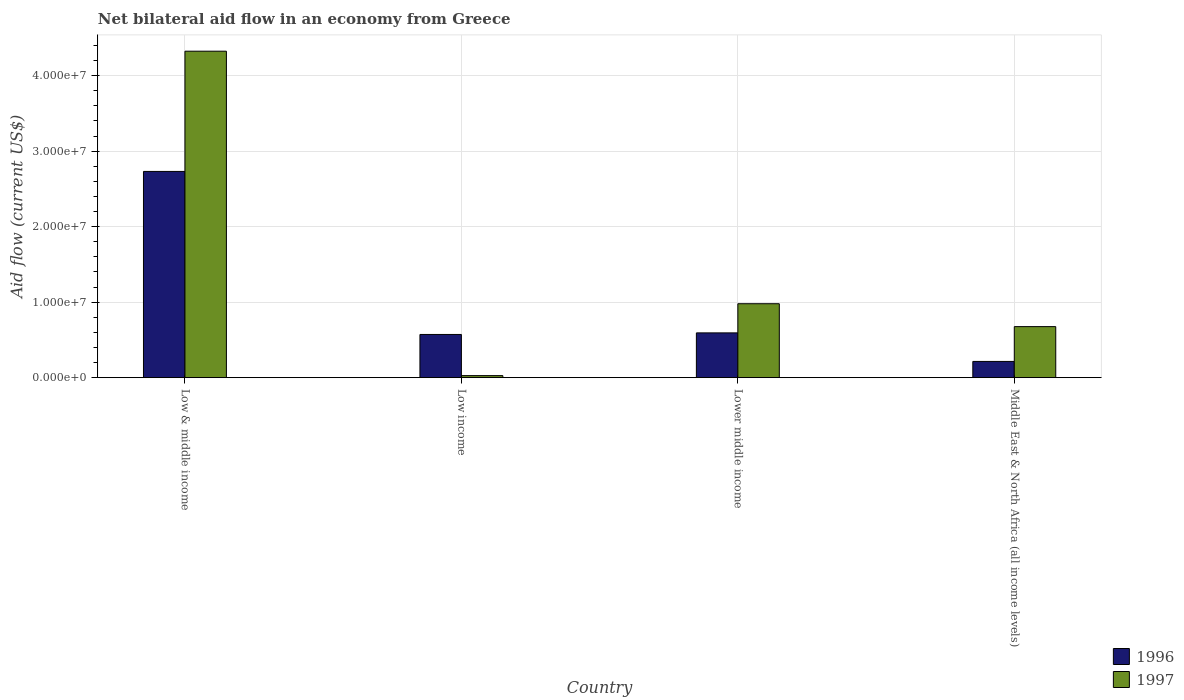How many different coloured bars are there?
Your response must be concise. 2. How many groups of bars are there?
Offer a very short reply. 4. Are the number of bars on each tick of the X-axis equal?
Your response must be concise. Yes. How many bars are there on the 4th tick from the right?
Make the answer very short. 2. What is the label of the 3rd group of bars from the left?
Offer a very short reply. Lower middle income. In how many cases, is the number of bars for a given country not equal to the number of legend labels?
Your answer should be very brief. 0. What is the net bilateral aid flow in 1997 in Low income?
Provide a short and direct response. 2.70e+05. Across all countries, what is the maximum net bilateral aid flow in 1996?
Ensure brevity in your answer.  2.73e+07. Across all countries, what is the minimum net bilateral aid flow in 1996?
Your response must be concise. 2.15e+06. In which country was the net bilateral aid flow in 1996 maximum?
Provide a short and direct response. Low & middle income. What is the total net bilateral aid flow in 1996 in the graph?
Your response must be concise. 4.11e+07. What is the difference between the net bilateral aid flow in 1997 in Low & middle income and the net bilateral aid flow in 1996 in Middle East & North Africa (all income levels)?
Provide a succinct answer. 4.11e+07. What is the average net bilateral aid flow in 1997 per country?
Give a very brief answer. 1.50e+07. What is the difference between the net bilateral aid flow of/in 1996 and net bilateral aid flow of/in 1997 in Low & middle income?
Provide a succinct answer. -1.59e+07. What is the ratio of the net bilateral aid flow in 1996 in Low income to that in Lower middle income?
Ensure brevity in your answer.  0.96. Is the net bilateral aid flow in 1997 in Lower middle income less than that in Middle East & North Africa (all income levels)?
Your response must be concise. No. What is the difference between the highest and the second highest net bilateral aid flow in 1997?
Provide a succinct answer. 3.34e+07. What is the difference between the highest and the lowest net bilateral aid flow in 1996?
Ensure brevity in your answer.  2.52e+07. What does the 1st bar from the left in Middle East & North Africa (all income levels) represents?
Your answer should be compact. 1996. Are the values on the major ticks of Y-axis written in scientific E-notation?
Provide a short and direct response. Yes. Does the graph contain grids?
Provide a short and direct response. Yes. Where does the legend appear in the graph?
Offer a terse response. Bottom right. How are the legend labels stacked?
Give a very brief answer. Vertical. What is the title of the graph?
Offer a very short reply. Net bilateral aid flow in an economy from Greece. Does "1987" appear as one of the legend labels in the graph?
Provide a succinct answer. No. What is the label or title of the X-axis?
Provide a short and direct response. Country. What is the label or title of the Y-axis?
Offer a terse response. Aid flow (current US$). What is the Aid flow (current US$) of 1996 in Low & middle income?
Provide a succinct answer. 2.73e+07. What is the Aid flow (current US$) of 1997 in Low & middle income?
Give a very brief answer. 4.32e+07. What is the Aid flow (current US$) in 1996 in Low income?
Make the answer very short. 5.72e+06. What is the Aid flow (current US$) of 1997 in Low income?
Keep it short and to the point. 2.70e+05. What is the Aid flow (current US$) in 1996 in Lower middle income?
Your response must be concise. 5.93e+06. What is the Aid flow (current US$) in 1997 in Lower middle income?
Provide a short and direct response. 9.79e+06. What is the Aid flow (current US$) of 1996 in Middle East & North Africa (all income levels)?
Your response must be concise. 2.15e+06. What is the Aid flow (current US$) of 1997 in Middle East & North Africa (all income levels)?
Offer a terse response. 6.76e+06. Across all countries, what is the maximum Aid flow (current US$) of 1996?
Ensure brevity in your answer.  2.73e+07. Across all countries, what is the maximum Aid flow (current US$) in 1997?
Your answer should be compact. 4.32e+07. Across all countries, what is the minimum Aid flow (current US$) of 1996?
Your response must be concise. 2.15e+06. What is the total Aid flow (current US$) of 1996 in the graph?
Give a very brief answer. 4.11e+07. What is the total Aid flow (current US$) of 1997 in the graph?
Your answer should be compact. 6.00e+07. What is the difference between the Aid flow (current US$) in 1996 in Low & middle income and that in Low income?
Provide a short and direct response. 2.16e+07. What is the difference between the Aid flow (current US$) in 1997 in Low & middle income and that in Low income?
Make the answer very short. 4.30e+07. What is the difference between the Aid flow (current US$) of 1996 in Low & middle income and that in Lower middle income?
Offer a terse response. 2.14e+07. What is the difference between the Aid flow (current US$) in 1997 in Low & middle income and that in Lower middle income?
Provide a short and direct response. 3.34e+07. What is the difference between the Aid flow (current US$) in 1996 in Low & middle income and that in Middle East & North Africa (all income levels)?
Provide a succinct answer. 2.52e+07. What is the difference between the Aid flow (current US$) of 1997 in Low & middle income and that in Middle East & North Africa (all income levels)?
Make the answer very short. 3.65e+07. What is the difference between the Aid flow (current US$) of 1997 in Low income and that in Lower middle income?
Your response must be concise. -9.52e+06. What is the difference between the Aid flow (current US$) of 1996 in Low income and that in Middle East & North Africa (all income levels)?
Ensure brevity in your answer.  3.57e+06. What is the difference between the Aid flow (current US$) of 1997 in Low income and that in Middle East & North Africa (all income levels)?
Ensure brevity in your answer.  -6.49e+06. What is the difference between the Aid flow (current US$) in 1996 in Lower middle income and that in Middle East & North Africa (all income levels)?
Your answer should be very brief. 3.78e+06. What is the difference between the Aid flow (current US$) in 1997 in Lower middle income and that in Middle East & North Africa (all income levels)?
Keep it short and to the point. 3.03e+06. What is the difference between the Aid flow (current US$) in 1996 in Low & middle income and the Aid flow (current US$) in 1997 in Low income?
Offer a very short reply. 2.70e+07. What is the difference between the Aid flow (current US$) in 1996 in Low & middle income and the Aid flow (current US$) in 1997 in Lower middle income?
Your answer should be very brief. 1.75e+07. What is the difference between the Aid flow (current US$) of 1996 in Low & middle income and the Aid flow (current US$) of 1997 in Middle East & North Africa (all income levels)?
Ensure brevity in your answer.  2.06e+07. What is the difference between the Aid flow (current US$) in 1996 in Low income and the Aid flow (current US$) in 1997 in Lower middle income?
Offer a very short reply. -4.07e+06. What is the difference between the Aid flow (current US$) in 1996 in Low income and the Aid flow (current US$) in 1997 in Middle East & North Africa (all income levels)?
Ensure brevity in your answer.  -1.04e+06. What is the difference between the Aid flow (current US$) in 1996 in Lower middle income and the Aid flow (current US$) in 1997 in Middle East & North Africa (all income levels)?
Provide a succinct answer. -8.30e+05. What is the average Aid flow (current US$) in 1996 per country?
Provide a short and direct response. 1.03e+07. What is the average Aid flow (current US$) in 1997 per country?
Your answer should be compact. 1.50e+07. What is the difference between the Aid flow (current US$) of 1996 and Aid flow (current US$) of 1997 in Low & middle income?
Ensure brevity in your answer.  -1.59e+07. What is the difference between the Aid flow (current US$) in 1996 and Aid flow (current US$) in 1997 in Low income?
Your answer should be compact. 5.45e+06. What is the difference between the Aid flow (current US$) in 1996 and Aid flow (current US$) in 1997 in Lower middle income?
Your answer should be very brief. -3.86e+06. What is the difference between the Aid flow (current US$) in 1996 and Aid flow (current US$) in 1997 in Middle East & North Africa (all income levels)?
Your answer should be compact. -4.61e+06. What is the ratio of the Aid flow (current US$) of 1996 in Low & middle income to that in Low income?
Provide a short and direct response. 4.77. What is the ratio of the Aid flow (current US$) in 1997 in Low & middle income to that in Low income?
Provide a short and direct response. 160.11. What is the ratio of the Aid flow (current US$) in 1996 in Low & middle income to that in Lower middle income?
Keep it short and to the point. 4.61. What is the ratio of the Aid flow (current US$) of 1997 in Low & middle income to that in Lower middle income?
Your answer should be compact. 4.42. What is the ratio of the Aid flow (current US$) of 1996 in Low & middle income to that in Middle East & North Africa (all income levels)?
Your answer should be compact. 12.7. What is the ratio of the Aid flow (current US$) of 1997 in Low & middle income to that in Middle East & North Africa (all income levels)?
Offer a very short reply. 6.39. What is the ratio of the Aid flow (current US$) of 1996 in Low income to that in Lower middle income?
Offer a very short reply. 0.96. What is the ratio of the Aid flow (current US$) of 1997 in Low income to that in Lower middle income?
Offer a very short reply. 0.03. What is the ratio of the Aid flow (current US$) in 1996 in Low income to that in Middle East & North Africa (all income levels)?
Provide a short and direct response. 2.66. What is the ratio of the Aid flow (current US$) in 1997 in Low income to that in Middle East & North Africa (all income levels)?
Provide a succinct answer. 0.04. What is the ratio of the Aid flow (current US$) in 1996 in Lower middle income to that in Middle East & North Africa (all income levels)?
Keep it short and to the point. 2.76. What is the ratio of the Aid flow (current US$) in 1997 in Lower middle income to that in Middle East & North Africa (all income levels)?
Give a very brief answer. 1.45. What is the difference between the highest and the second highest Aid flow (current US$) in 1996?
Give a very brief answer. 2.14e+07. What is the difference between the highest and the second highest Aid flow (current US$) of 1997?
Your response must be concise. 3.34e+07. What is the difference between the highest and the lowest Aid flow (current US$) of 1996?
Provide a short and direct response. 2.52e+07. What is the difference between the highest and the lowest Aid flow (current US$) in 1997?
Ensure brevity in your answer.  4.30e+07. 